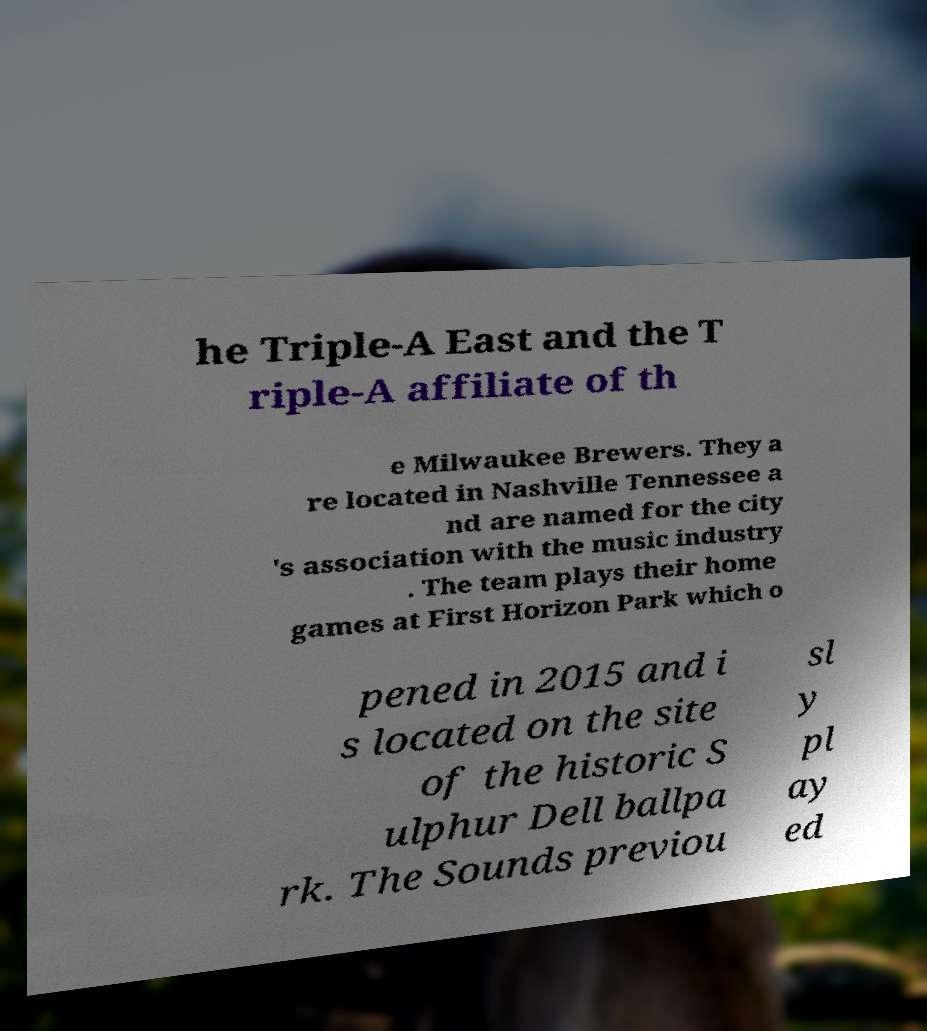What messages or text are displayed in this image? I need them in a readable, typed format. he Triple-A East and the T riple-A affiliate of th e Milwaukee Brewers. They a re located in Nashville Tennessee a nd are named for the city 's association with the music industry . The team plays their home games at First Horizon Park which o pened in 2015 and i s located on the site of the historic S ulphur Dell ballpa rk. The Sounds previou sl y pl ay ed 